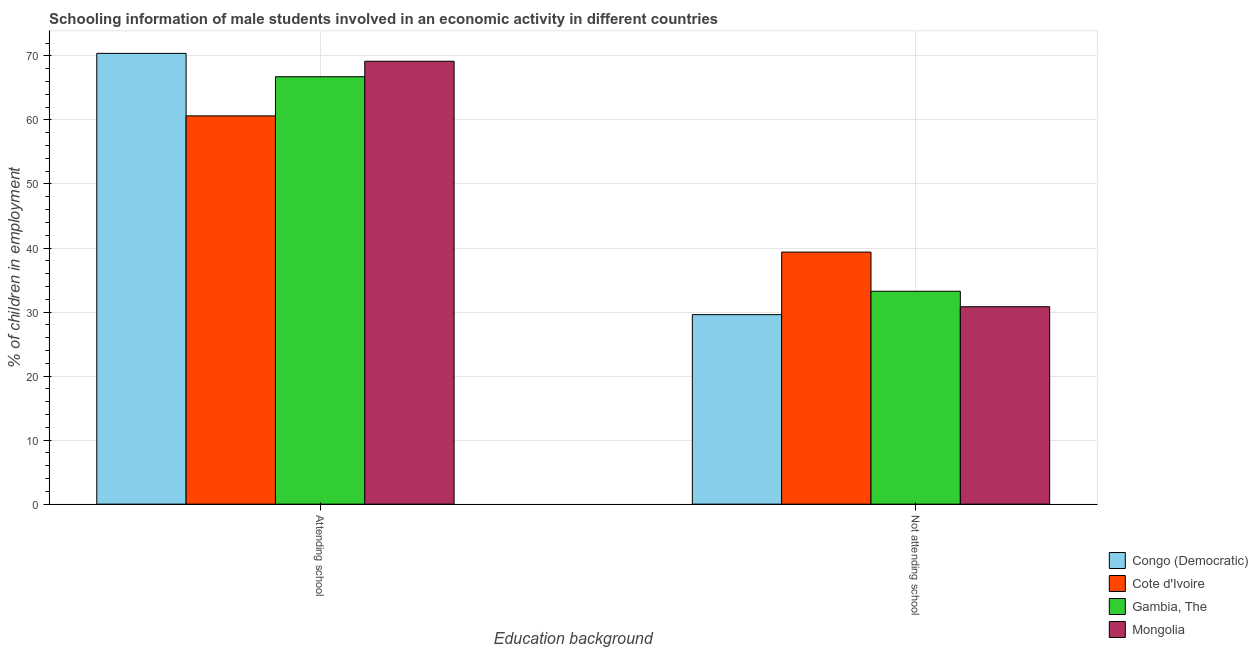How many different coloured bars are there?
Make the answer very short. 4. How many groups of bars are there?
Ensure brevity in your answer.  2. Are the number of bars on each tick of the X-axis equal?
Keep it short and to the point. Yes. How many bars are there on the 1st tick from the right?
Make the answer very short. 4. What is the label of the 2nd group of bars from the left?
Your answer should be very brief. Not attending school. What is the percentage of employed males who are not attending school in Gambia, The?
Offer a very short reply. 33.25. Across all countries, what is the maximum percentage of employed males who are not attending school?
Your response must be concise. 39.36. Across all countries, what is the minimum percentage of employed males who are not attending school?
Ensure brevity in your answer.  29.6. In which country was the percentage of employed males who are not attending school maximum?
Provide a succinct answer. Cote d'Ivoire. In which country was the percentage of employed males who are attending school minimum?
Provide a short and direct response. Cote d'Ivoire. What is the total percentage of employed males who are not attending school in the graph?
Offer a very short reply. 133.05. What is the difference between the percentage of employed males who are attending school in Cote d'Ivoire and that in Congo (Democratic)?
Ensure brevity in your answer.  -9.76. What is the difference between the percentage of employed males who are attending school in Cote d'Ivoire and the percentage of employed males who are not attending school in Mongolia?
Give a very brief answer. 29.8. What is the average percentage of employed males who are attending school per country?
Your answer should be compact. 66.74. What is the difference between the percentage of employed males who are attending school and percentage of employed males who are not attending school in Mongolia?
Your answer should be compact. 38.34. What is the ratio of the percentage of employed males who are attending school in Gambia, The to that in Mongolia?
Your answer should be very brief. 0.97. In how many countries, is the percentage of employed males who are not attending school greater than the average percentage of employed males who are not attending school taken over all countries?
Offer a very short reply. 1. What does the 3rd bar from the left in Not attending school represents?
Keep it short and to the point. Gambia, The. What does the 1st bar from the right in Not attending school represents?
Provide a succinct answer. Mongolia. How many bars are there?
Offer a terse response. 8. How many countries are there in the graph?
Offer a very short reply. 4. Are the values on the major ticks of Y-axis written in scientific E-notation?
Make the answer very short. No. How are the legend labels stacked?
Offer a terse response. Vertical. What is the title of the graph?
Provide a succinct answer. Schooling information of male students involved in an economic activity in different countries. What is the label or title of the X-axis?
Your response must be concise. Education background. What is the label or title of the Y-axis?
Your response must be concise. % of children in employment. What is the % of children in employment of Congo (Democratic) in Attending school?
Give a very brief answer. 70.4. What is the % of children in employment of Cote d'Ivoire in Attending school?
Ensure brevity in your answer.  60.64. What is the % of children in employment of Gambia, The in Attending school?
Provide a succinct answer. 66.75. What is the % of children in employment of Mongolia in Attending school?
Ensure brevity in your answer.  69.17. What is the % of children in employment of Congo (Democratic) in Not attending school?
Provide a succinct answer. 29.6. What is the % of children in employment of Cote d'Ivoire in Not attending school?
Your response must be concise. 39.36. What is the % of children in employment of Gambia, The in Not attending school?
Provide a short and direct response. 33.25. What is the % of children in employment of Mongolia in Not attending school?
Give a very brief answer. 30.83. Across all Education background, what is the maximum % of children in employment in Congo (Democratic)?
Offer a terse response. 70.4. Across all Education background, what is the maximum % of children in employment in Cote d'Ivoire?
Your answer should be very brief. 60.64. Across all Education background, what is the maximum % of children in employment in Gambia, The?
Give a very brief answer. 66.75. Across all Education background, what is the maximum % of children in employment of Mongolia?
Your answer should be very brief. 69.17. Across all Education background, what is the minimum % of children in employment in Congo (Democratic)?
Your answer should be very brief. 29.6. Across all Education background, what is the minimum % of children in employment in Cote d'Ivoire?
Your response must be concise. 39.36. Across all Education background, what is the minimum % of children in employment of Gambia, The?
Keep it short and to the point. 33.25. Across all Education background, what is the minimum % of children in employment of Mongolia?
Make the answer very short. 30.83. What is the total % of children in employment of Congo (Democratic) in the graph?
Keep it short and to the point. 100. What is the total % of children in employment in Gambia, The in the graph?
Offer a very short reply. 100. What is the difference between the % of children in employment in Congo (Democratic) in Attending school and that in Not attending school?
Offer a terse response. 40.8. What is the difference between the % of children in employment in Cote d'Ivoire in Attending school and that in Not attending school?
Provide a succinct answer. 21.27. What is the difference between the % of children in employment of Gambia, The in Attending school and that in Not attending school?
Ensure brevity in your answer.  33.5. What is the difference between the % of children in employment of Mongolia in Attending school and that in Not attending school?
Your answer should be very brief. 38.34. What is the difference between the % of children in employment in Congo (Democratic) in Attending school and the % of children in employment in Cote d'Ivoire in Not attending school?
Ensure brevity in your answer.  31.04. What is the difference between the % of children in employment of Congo (Democratic) in Attending school and the % of children in employment of Gambia, The in Not attending school?
Ensure brevity in your answer.  37.15. What is the difference between the % of children in employment in Congo (Democratic) in Attending school and the % of children in employment in Mongolia in Not attending school?
Offer a terse response. 39.57. What is the difference between the % of children in employment in Cote d'Ivoire in Attending school and the % of children in employment in Gambia, The in Not attending school?
Your answer should be compact. 27.39. What is the difference between the % of children in employment of Cote d'Ivoire in Attending school and the % of children in employment of Mongolia in Not attending school?
Your answer should be very brief. 29.8. What is the difference between the % of children in employment of Gambia, The in Attending school and the % of children in employment of Mongolia in Not attending school?
Your response must be concise. 35.92. What is the average % of children in employment of Congo (Democratic) per Education background?
Your response must be concise. 50. What is the average % of children in employment in Cote d'Ivoire per Education background?
Give a very brief answer. 50. What is the difference between the % of children in employment in Congo (Democratic) and % of children in employment in Cote d'Ivoire in Attending school?
Your answer should be very brief. 9.76. What is the difference between the % of children in employment in Congo (Democratic) and % of children in employment in Gambia, The in Attending school?
Provide a succinct answer. 3.65. What is the difference between the % of children in employment in Congo (Democratic) and % of children in employment in Mongolia in Attending school?
Your answer should be compact. 1.23. What is the difference between the % of children in employment of Cote d'Ivoire and % of children in employment of Gambia, The in Attending school?
Provide a succinct answer. -6.12. What is the difference between the % of children in employment in Cote d'Ivoire and % of children in employment in Mongolia in Attending school?
Provide a succinct answer. -8.53. What is the difference between the % of children in employment in Gambia, The and % of children in employment in Mongolia in Attending school?
Give a very brief answer. -2.42. What is the difference between the % of children in employment of Congo (Democratic) and % of children in employment of Cote d'Ivoire in Not attending school?
Your answer should be very brief. -9.76. What is the difference between the % of children in employment in Congo (Democratic) and % of children in employment in Gambia, The in Not attending school?
Ensure brevity in your answer.  -3.65. What is the difference between the % of children in employment of Congo (Democratic) and % of children in employment of Mongolia in Not attending school?
Your answer should be very brief. -1.23. What is the difference between the % of children in employment in Cote d'Ivoire and % of children in employment in Gambia, The in Not attending school?
Give a very brief answer. 6.12. What is the difference between the % of children in employment in Cote d'Ivoire and % of children in employment in Mongolia in Not attending school?
Provide a succinct answer. 8.53. What is the difference between the % of children in employment in Gambia, The and % of children in employment in Mongolia in Not attending school?
Keep it short and to the point. 2.42. What is the ratio of the % of children in employment of Congo (Democratic) in Attending school to that in Not attending school?
Provide a succinct answer. 2.38. What is the ratio of the % of children in employment in Cote d'Ivoire in Attending school to that in Not attending school?
Provide a short and direct response. 1.54. What is the ratio of the % of children in employment in Gambia, The in Attending school to that in Not attending school?
Give a very brief answer. 2.01. What is the ratio of the % of children in employment of Mongolia in Attending school to that in Not attending school?
Offer a terse response. 2.24. What is the difference between the highest and the second highest % of children in employment in Congo (Democratic)?
Offer a terse response. 40.8. What is the difference between the highest and the second highest % of children in employment of Cote d'Ivoire?
Keep it short and to the point. 21.27. What is the difference between the highest and the second highest % of children in employment of Gambia, The?
Offer a very short reply. 33.5. What is the difference between the highest and the second highest % of children in employment in Mongolia?
Keep it short and to the point. 38.34. What is the difference between the highest and the lowest % of children in employment of Congo (Democratic)?
Ensure brevity in your answer.  40.8. What is the difference between the highest and the lowest % of children in employment in Cote d'Ivoire?
Your answer should be very brief. 21.27. What is the difference between the highest and the lowest % of children in employment in Gambia, The?
Offer a very short reply. 33.5. What is the difference between the highest and the lowest % of children in employment in Mongolia?
Ensure brevity in your answer.  38.34. 